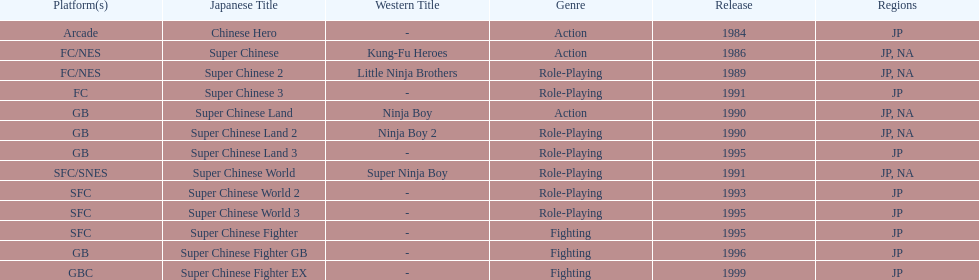When was the last super chinese game released? 1999. Parse the table in full. {'header': ['Platform(s)', 'Japanese Title', 'Western Title', 'Genre', 'Release', 'Regions'], 'rows': [['Arcade', 'Chinese Hero', '-', 'Action', '1984', 'JP'], ['FC/NES', 'Super Chinese', 'Kung-Fu Heroes', 'Action', '1986', 'JP, NA'], ['FC/NES', 'Super Chinese 2', 'Little Ninja Brothers', 'Role-Playing', '1989', 'JP, NA'], ['FC', 'Super Chinese 3', '-', 'Role-Playing', '1991', 'JP'], ['GB', 'Super Chinese Land', 'Ninja Boy', 'Action', '1990', 'JP, NA'], ['GB', 'Super Chinese Land 2', 'Ninja Boy 2', 'Role-Playing', '1990', 'JP, NA'], ['GB', 'Super Chinese Land 3', '-', 'Role-Playing', '1995', 'JP'], ['SFC/SNES', 'Super Chinese World', 'Super Ninja Boy', 'Role-Playing', '1991', 'JP, NA'], ['SFC', 'Super Chinese World 2', '-', 'Role-Playing', '1993', 'JP'], ['SFC', 'Super Chinese World 3', '-', 'Role-Playing', '1995', 'JP'], ['SFC', 'Super Chinese Fighter', '-', 'Fighting', '1995', 'JP'], ['GB', 'Super Chinese Fighter GB', '-', 'Fighting', '1996', 'JP'], ['GBC', 'Super Chinese Fighter EX', '-', 'Fighting', '1999', 'JP']]} 